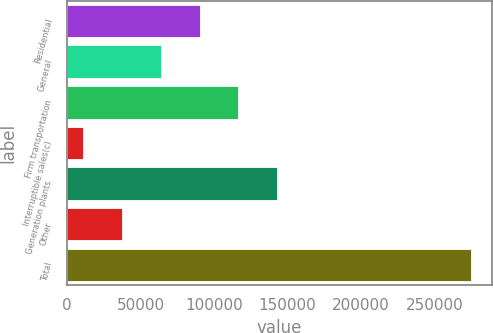Convert chart. <chart><loc_0><loc_0><loc_500><loc_500><bar_chart><fcel>Residential<fcel>General<fcel>Firm transportation<fcel>Interruptible sales(c)<fcel>Generation plants<fcel>Other<fcel>Total<nl><fcel>90162.1<fcel>63741.4<fcel>116583<fcel>10900<fcel>143004<fcel>37320.7<fcel>275107<nl></chart> 